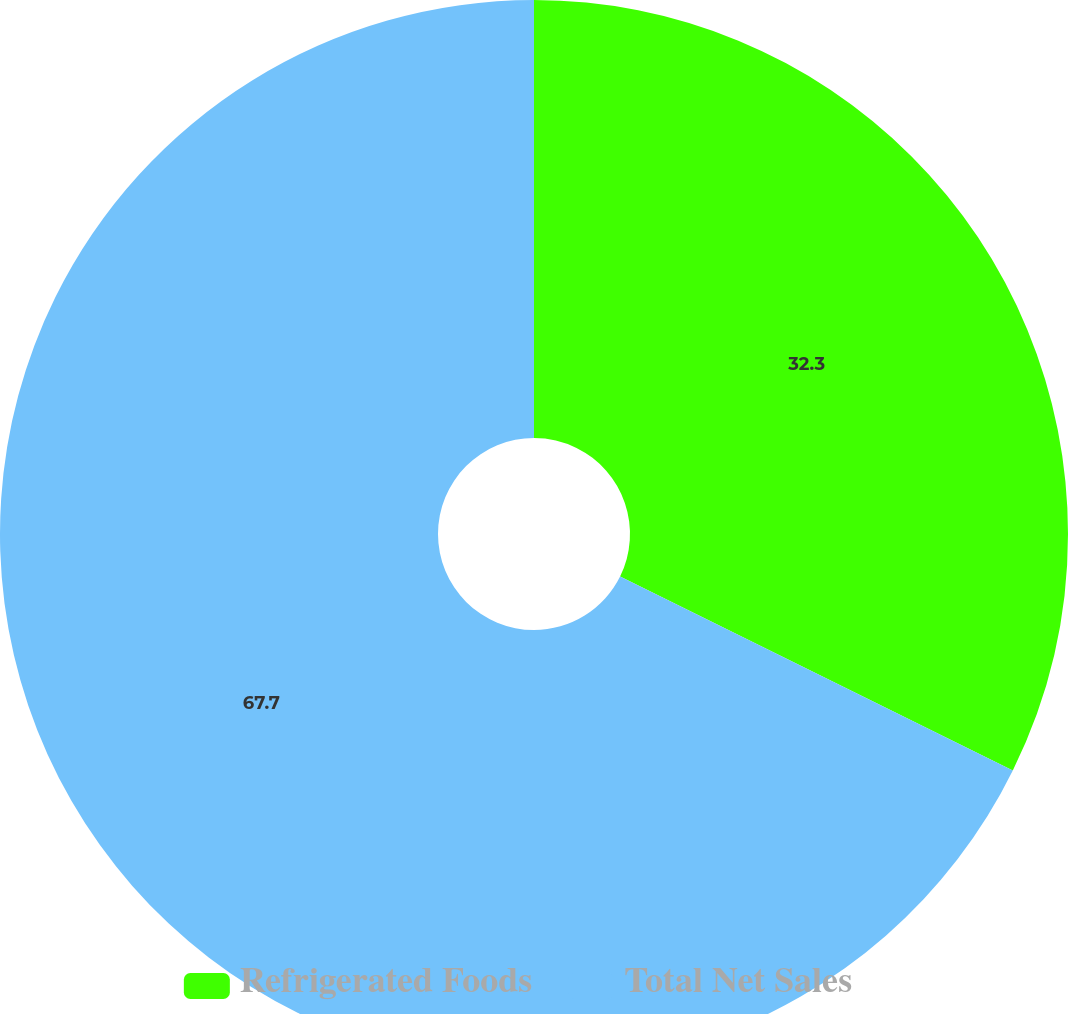Convert chart. <chart><loc_0><loc_0><loc_500><loc_500><pie_chart><fcel>Refrigerated Foods<fcel>Total Net Sales<nl><fcel>32.3%<fcel>67.7%<nl></chart> 